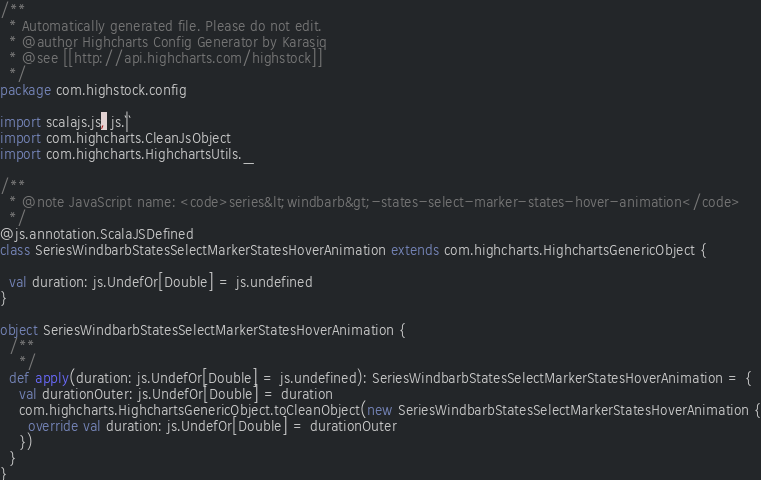Convert code to text. <code><loc_0><loc_0><loc_500><loc_500><_Scala_>/**
  * Automatically generated file. Please do not edit.
  * @author Highcharts Config Generator by Karasiq
  * @see [[http://api.highcharts.com/highstock]]
  */
package com.highstock.config

import scalajs.js, js.`|`
import com.highcharts.CleanJsObject
import com.highcharts.HighchartsUtils._

/**
  * @note JavaScript name: <code>series&lt;windbarb&gt;-states-select-marker-states-hover-animation</code>
  */
@js.annotation.ScalaJSDefined
class SeriesWindbarbStatesSelectMarkerStatesHoverAnimation extends com.highcharts.HighchartsGenericObject {

  val duration: js.UndefOr[Double] = js.undefined
}

object SeriesWindbarbStatesSelectMarkerStatesHoverAnimation {
  /**
    */
  def apply(duration: js.UndefOr[Double] = js.undefined): SeriesWindbarbStatesSelectMarkerStatesHoverAnimation = {
    val durationOuter: js.UndefOr[Double] = duration
    com.highcharts.HighchartsGenericObject.toCleanObject(new SeriesWindbarbStatesSelectMarkerStatesHoverAnimation {
      override val duration: js.UndefOr[Double] = durationOuter
    })
  }
}
</code> 